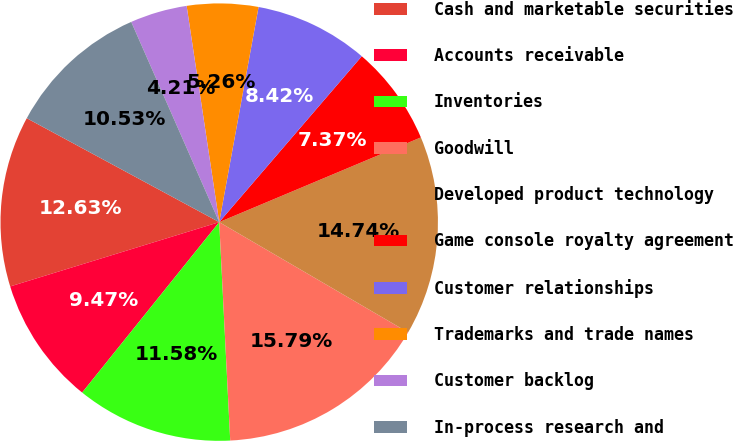<chart> <loc_0><loc_0><loc_500><loc_500><pie_chart><fcel>Cash and marketable securities<fcel>Accounts receivable<fcel>Inventories<fcel>Goodwill<fcel>Developed product technology<fcel>Game console royalty agreement<fcel>Customer relationships<fcel>Trademarks and trade names<fcel>Customer backlog<fcel>In-process research and<nl><fcel>12.63%<fcel>9.47%<fcel>11.58%<fcel>15.79%<fcel>14.74%<fcel>7.37%<fcel>8.42%<fcel>5.26%<fcel>4.21%<fcel>10.53%<nl></chart> 